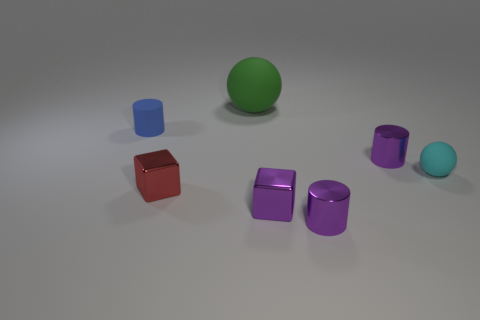Add 2 tiny blue rubber cylinders. How many objects exist? 9 Subtract all red blocks. How many blocks are left? 1 Subtract all purple cylinders. How many cylinders are left? 1 Subtract 2 cylinders. How many cylinders are left? 1 Subtract all cylinders. How many objects are left? 4 Subtract all purple cylinders. Subtract all red cubes. How many cylinders are left? 1 Subtract all gray spheres. How many purple cylinders are left? 2 Subtract all cylinders. Subtract all purple shiny blocks. How many objects are left? 3 Add 6 blue objects. How many blue objects are left? 7 Add 1 red metal things. How many red metal things exist? 2 